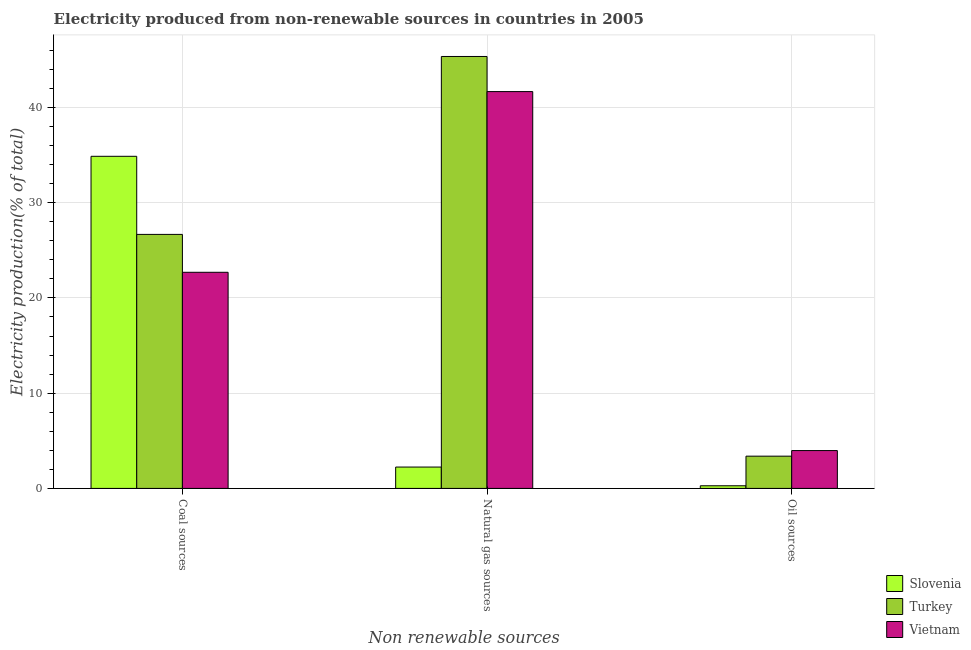Are the number of bars per tick equal to the number of legend labels?
Give a very brief answer. Yes. How many bars are there on the 2nd tick from the right?
Provide a short and direct response. 3. What is the label of the 1st group of bars from the left?
Your answer should be compact. Coal sources. What is the percentage of electricity produced by coal in Turkey?
Offer a very short reply. 26.67. Across all countries, what is the maximum percentage of electricity produced by coal?
Offer a very short reply. 34.87. Across all countries, what is the minimum percentage of electricity produced by oil sources?
Your response must be concise. 0.28. In which country was the percentage of electricity produced by oil sources maximum?
Your answer should be compact. Vietnam. In which country was the percentage of electricity produced by natural gas minimum?
Offer a terse response. Slovenia. What is the total percentage of electricity produced by oil sources in the graph?
Keep it short and to the point. 7.64. What is the difference between the percentage of electricity produced by coal in Vietnam and that in Slovenia?
Offer a very short reply. -12.18. What is the difference between the percentage of electricity produced by oil sources in Vietnam and the percentage of electricity produced by coal in Turkey?
Provide a succinct answer. -22.7. What is the average percentage of electricity produced by coal per country?
Your answer should be very brief. 28.08. What is the difference between the percentage of electricity produced by oil sources and percentage of electricity produced by coal in Slovenia?
Your response must be concise. -34.59. In how many countries, is the percentage of electricity produced by oil sources greater than 20 %?
Make the answer very short. 0. What is the ratio of the percentage of electricity produced by natural gas in Vietnam to that in Slovenia?
Your answer should be very brief. 18.58. Is the difference between the percentage of electricity produced by natural gas in Slovenia and Vietnam greater than the difference between the percentage of electricity produced by oil sources in Slovenia and Vietnam?
Provide a short and direct response. No. What is the difference between the highest and the second highest percentage of electricity produced by natural gas?
Give a very brief answer. 3.69. What is the difference between the highest and the lowest percentage of electricity produced by oil sources?
Make the answer very short. 3.7. In how many countries, is the percentage of electricity produced by oil sources greater than the average percentage of electricity produced by oil sources taken over all countries?
Offer a very short reply. 2. Is the sum of the percentage of electricity produced by oil sources in Vietnam and Turkey greater than the maximum percentage of electricity produced by natural gas across all countries?
Keep it short and to the point. No. What does the 1st bar from the left in Coal sources represents?
Provide a short and direct response. Slovenia. What does the 2nd bar from the right in Natural gas sources represents?
Your response must be concise. Turkey. Is it the case that in every country, the sum of the percentage of electricity produced by coal and percentage of electricity produced by natural gas is greater than the percentage of electricity produced by oil sources?
Give a very brief answer. Yes. Are all the bars in the graph horizontal?
Ensure brevity in your answer.  No. How many countries are there in the graph?
Your answer should be very brief. 3. Does the graph contain any zero values?
Your answer should be compact. No. What is the title of the graph?
Provide a short and direct response. Electricity produced from non-renewable sources in countries in 2005. Does "Tanzania" appear as one of the legend labels in the graph?
Provide a succinct answer. No. What is the label or title of the X-axis?
Your response must be concise. Non renewable sources. What is the Electricity production(% of total) of Slovenia in Coal sources?
Offer a very short reply. 34.87. What is the Electricity production(% of total) in Turkey in Coal sources?
Make the answer very short. 26.67. What is the Electricity production(% of total) of Vietnam in Coal sources?
Your response must be concise. 22.69. What is the Electricity production(% of total) of Slovenia in Natural gas sources?
Give a very brief answer. 2.24. What is the Electricity production(% of total) of Turkey in Natural gas sources?
Offer a terse response. 45.35. What is the Electricity production(% of total) of Vietnam in Natural gas sources?
Offer a terse response. 41.66. What is the Electricity production(% of total) of Slovenia in Oil sources?
Offer a terse response. 0.28. What is the Electricity production(% of total) of Turkey in Oil sources?
Offer a terse response. 3.39. What is the Electricity production(% of total) of Vietnam in Oil sources?
Your response must be concise. 3.97. Across all Non renewable sources, what is the maximum Electricity production(% of total) of Slovenia?
Offer a terse response. 34.87. Across all Non renewable sources, what is the maximum Electricity production(% of total) in Turkey?
Provide a succinct answer. 45.35. Across all Non renewable sources, what is the maximum Electricity production(% of total) in Vietnam?
Make the answer very short. 41.66. Across all Non renewable sources, what is the minimum Electricity production(% of total) in Slovenia?
Ensure brevity in your answer.  0.28. Across all Non renewable sources, what is the minimum Electricity production(% of total) of Turkey?
Provide a succinct answer. 3.39. Across all Non renewable sources, what is the minimum Electricity production(% of total) in Vietnam?
Your response must be concise. 3.97. What is the total Electricity production(% of total) of Slovenia in the graph?
Keep it short and to the point. 37.39. What is the total Electricity production(% of total) of Turkey in the graph?
Keep it short and to the point. 75.4. What is the total Electricity production(% of total) in Vietnam in the graph?
Your answer should be very brief. 68.33. What is the difference between the Electricity production(% of total) in Slovenia in Coal sources and that in Natural gas sources?
Your answer should be compact. 32.63. What is the difference between the Electricity production(% of total) of Turkey in Coal sources and that in Natural gas sources?
Make the answer very short. -18.68. What is the difference between the Electricity production(% of total) of Vietnam in Coal sources and that in Natural gas sources?
Your answer should be compact. -18.97. What is the difference between the Electricity production(% of total) in Slovenia in Coal sources and that in Oil sources?
Make the answer very short. 34.59. What is the difference between the Electricity production(% of total) in Turkey in Coal sources and that in Oil sources?
Keep it short and to the point. 23.28. What is the difference between the Electricity production(% of total) in Vietnam in Coal sources and that in Oil sources?
Your answer should be compact. 18.72. What is the difference between the Electricity production(% of total) in Slovenia in Natural gas sources and that in Oil sources?
Give a very brief answer. 1.96. What is the difference between the Electricity production(% of total) of Turkey in Natural gas sources and that in Oil sources?
Provide a succinct answer. 41.96. What is the difference between the Electricity production(% of total) in Vietnam in Natural gas sources and that in Oil sources?
Your answer should be very brief. 37.69. What is the difference between the Electricity production(% of total) in Slovenia in Coal sources and the Electricity production(% of total) in Turkey in Natural gas sources?
Offer a terse response. -10.48. What is the difference between the Electricity production(% of total) of Slovenia in Coal sources and the Electricity production(% of total) of Vietnam in Natural gas sources?
Keep it short and to the point. -6.79. What is the difference between the Electricity production(% of total) of Turkey in Coal sources and the Electricity production(% of total) of Vietnam in Natural gas sources?
Your response must be concise. -14.99. What is the difference between the Electricity production(% of total) in Slovenia in Coal sources and the Electricity production(% of total) in Turkey in Oil sources?
Make the answer very short. 31.48. What is the difference between the Electricity production(% of total) of Slovenia in Coal sources and the Electricity production(% of total) of Vietnam in Oil sources?
Provide a short and direct response. 30.89. What is the difference between the Electricity production(% of total) in Turkey in Coal sources and the Electricity production(% of total) in Vietnam in Oil sources?
Your response must be concise. 22.7. What is the difference between the Electricity production(% of total) in Slovenia in Natural gas sources and the Electricity production(% of total) in Turkey in Oil sources?
Provide a short and direct response. -1.14. What is the difference between the Electricity production(% of total) in Slovenia in Natural gas sources and the Electricity production(% of total) in Vietnam in Oil sources?
Your response must be concise. -1.73. What is the difference between the Electricity production(% of total) in Turkey in Natural gas sources and the Electricity production(% of total) in Vietnam in Oil sources?
Give a very brief answer. 41.38. What is the average Electricity production(% of total) in Slovenia per Non renewable sources?
Your answer should be compact. 12.46. What is the average Electricity production(% of total) in Turkey per Non renewable sources?
Give a very brief answer. 25.13. What is the average Electricity production(% of total) in Vietnam per Non renewable sources?
Offer a terse response. 22.78. What is the difference between the Electricity production(% of total) in Slovenia and Electricity production(% of total) in Turkey in Coal sources?
Your answer should be very brief. 8.2. What is the difference between the Electricity production(% of total) in Slovenia and Electricity production(% of total) in Vietnam in Coal sources?
Provide a short and direct response. 12.18. What is the difference between the Electricity production(% of total) in Turkey and Electricity production(% of total) in Vietnam in Coal sources?
Keep it short and to the point. 3.98. What is the difference between the Electricity production(% of total) in Slovenia and Electricity production(% of total) in Turkey in Natural gas sources?
Offer a very short reply. -43.11. What is the difference between the Electricity production(% of total) of Slovenia and Electricity production(% of total) of Vietnam in Natural gas sources?
Keep it short and to the point. -39.42. What is the difference between the Electricity production(% of total) in Turkey and Electricity production(% of total) in Vietnam in Natural gas sources?
Your response must be concise. 3.69. What is the difference between the Electricity production(% of total) of Slovenia and Electricity production(% of total) of Turkey in Oil sources?
Provide a succinct answer. -3.11. What is the difference between the Electricity production(% of total) of Slovenia and Electricity production(% of total) of Vietnam in Oil sources?
Provide a succinct answer. -3.7. What is the difference between the Electricity production(% of total) of Turkey and Electricity production(% of total) of Vietnam in Oil sources?
Offer a very short reply. -0.59. What is the ratio of the Electricity production(% of total) in Slovenia in Coal sources to that in Natural gas sources?
Offer a very short reply. 15.55. What is the ratio of the Electricity production(% of total) in Turkey in Coal sources to that in Natural gas sources?
Offer a terse response. 0.59. What is the ratio of the Electricity production(% of total) in Vietnam in Coal sources to that in Natural gas sources?
Your answer should be very brief. 0.54. What is the ratio of the Electricity production(% of total) of Slovenia in Coal sources to that in Oil sources?
Provide a succinct answer. 125.5. What is the ratio of the Electricity production(% of total) of Turkey in Coal sources to that in Oil sources?
Make the answer very short. 7.88. What is the ratio of the Electricity production(% of total) of Vietnam in Coal sources to that in Oil sources?
Keep it short and to the point. 5.71. What is the ratio of the Electricity production(% of total) of Slovenia in Natural gas sources to that in Oil sources?
Your answer should be very brief. 8.07. What is the ratio of the Electricity production(% of total) in Turkey in Natural gas sources to that in Oil sources?
Provide a succinct answer. 13.39. What is the ratio of the Electricity production(% of total) in Vietnam in Natural gas sources to that in Oil sources?
Provide a succinct answer. 10.48. What is the difference between the highest and the second highest Electricity production(% of total) in Slovenia?
Offer a terse response. 32.63. What is the difference between the highest and the second highest Electricity production(% of total) in Turkey?
Your answer should be compact. 18.68. What is the difference between the highest and the second highest Electricity production(% of total) in Vietnam?
Make the answer very short. 18.97. What is the difference between the highest and the lowest Electricity production(% of total) in Slovenia?
Offer a very short reply. 34.59. What is the difference between the highest and the lowest Electricity production(% of total) of Turkey?
Your response must be concise. 41.96. What is the difference between the highest and the lowest Electricity production(% of total) in Vietnam?
Provide a short and direct response. 37.69. 